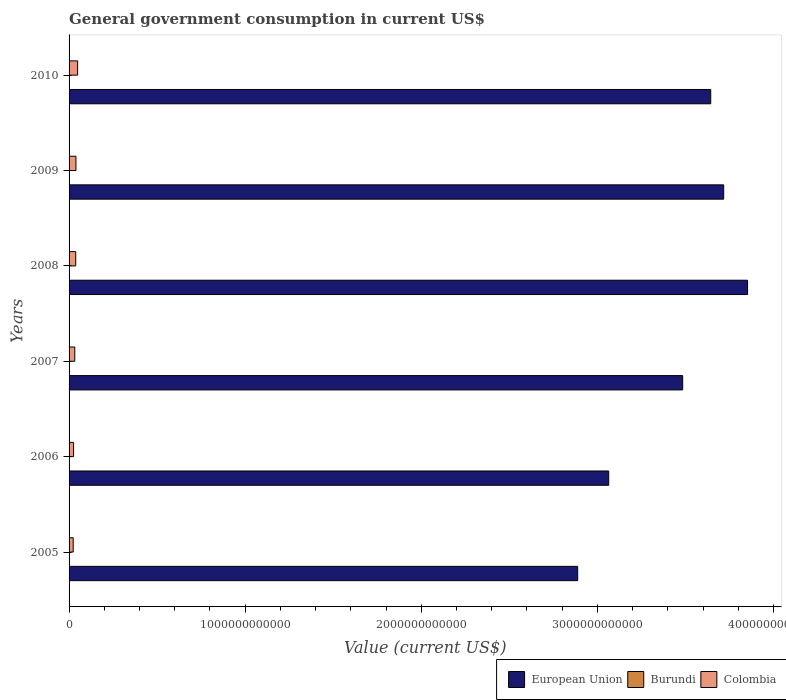How many different coloured bars are there?
Your answer should be compact. 3. How many groups of bars are there?
Offer a very short reply. 6. Are the number of bars per tick equal to the number of legend labels?
Keep it short and to the point. Yes. Are the number of bars on each tick of the Y-axis equal?
Keep it short and to the point. Yes. In how many cases, is the number of bars for a given year not equal to the number of legend labels?
Provide a succinct answer. 0. What is the government conusmption in European Union in 2007?
Your answer should be very brief. 3.48e+12. Across all years, what is the maximum government conusmption in Colombia?
Your answer should be compact. 4.86e+1. Across all years, what is the minimum government conusmption in Colombia?
Provide a short and direct response. 2.35e+1. In which year was the government conusmption in Colombia minimum?
Your answer should be compact. 2005. What is the total government conusmption in Colombia in the graph?
Your answer should be compact. 2.07e+11. What is the difference between the government conusmption in Burundi in 2005 and that in 2010?
Ensure brevity in your answer.  -4.28e+08. What is the difference between the government conusmption in Colombia in 2005 and the government conusmption in European Union in 2009?
Your response must be concise. -3.69e+12. What is the average government conusmption in Burundi per year?
Your answer should be compact. 4.12e+08. In the year 2010, what is the difference between the government conusmption in Burundi and government conusmption in European Union?
Offer a terse response. -3.64e+12. What is the ratio of the government conusmption in European Union in 2007 to that in 2008?
Make the answer very short. 0.9. Is the difference between the government conusmption in Burundi in 2008 and 2010 greater than the difference between the government conusmption in European Union in 2008 and 2010?
Provide a short and direct response. No. What is the difference between the highest and the second highest government conusmption in Colombia?
Your answer should be very brief. 9.53e+09. What is the difference between the highest and the lowest government conusmption in European Union?
Offer a very short reply. 9.65e+11. What does the 2nd bar from the top in 2008 represents?
Your answer should be very brief. Burundi. How many bars are there?
Your response must be concise. 18. Are all the bars in the graph horizontal?
Provide a succinct answer. Yes. How many years are there in the graph?
Provide a short and direct response. 6. What is the difference between two consecutive major ticks on the X-axis?
Your response must be concise. 1.00e+12. How many legend labels are there?
Give a very brief answer. 3. How are the legend labels stacked?
Provide a short and direct response. Horizontal. What is the title of the graph?
Ensure brevity in your answer.  General government consumption in current US$. What is the label or title of the X-axis?
Offer a very short reply. Value (current US$). What is the label or title of the Y-axis?
Your response must be concise. Years. What is the Value (current US$) of European Union in 2005?
Your response must be concise. 2.89e+12. What is the Value (current US$) in Burundi in 2005?
Make the answer very short. 2.12e+08. What is the Value (current US$) in Colombia in 2005?
Make the answer very short. 2.35e+1. What is the Value (current US$) in European Union in 2006?
Provide a short and direct response. 3.06e+12. What is the Value (current US$) of Burundi in 2006?
Give a very brief answer. 2.52e+08. What is the Value (current US$) in Colombia in 2006?
Your answer should be very brief. 2.55e+1. What is the Value (current US$) in European Union in 2007?
Make the answer very short. 3.48e+12. What is the Value (current US$) of Burundi in 2007?
Offer a terse response. 3.80e+08. What is the Value (current US$) in Colombia in 2007?
Your response must be concise. 3.24e+1. What is the Value (current US$) in European Union in 2008?
Your response must be concise. 3.85e+12. What is the Value (current US$) of Burundi in 2008?
Offer a very short reply. 4.86e+08. What is the Value (current US$) in Colombia in 2008?
Your response must be concise. 3.79e+1. What is the Value (current US$) of European Union in 2009?
Ensure brevity in your answer.  3.72e+12. What is the Value (current US$) of Burundi in 2009?
Give a very brief answer. 5.02e+08. What is the Value (current US$) of Colombia in 2009?
Give a very brief answer. 3.91e+1. What is the Value (current US$) in European Union in 2010?
Provide a succinct answer. 3.64e+12. What is the Value (current US$) of Burundi in 2010?
Provide a short and direct response. 6.40e+08. What is the Value (current US$) of Colombia in 2010?
Offer a very short reply. 4.86e+1. Across all years, what is the maximum Value (current US$) in European Union?
Provide a short and direct response. 3.85e+12. Across all years, what is the maximum Value (current US$) of Burundi?
Your answer should be compact. 6.40e+08. Across all years, what is the maximum Value (current US$) of Colombia?
Offer a very short reply. 4.86e+1. Across all years, what is the minimum Value (current US$) in European Union?
Your answer should be compact. 2.89e+12. Across all years, what is the minimum Value (current US$) of Burundi?
Keep it short and to the point. 2.12e+08. Across all years, what is the minimum Value (current US$) of Colombia?
Your answer should be very brief. 2.35e+1. What is the total Value (current US$) of European Union in the graph?
Keep it short and to the point. 2.07e+13. What is the total Value (current US$) of Burundi in the graph?
Provide a short and direct response. 2.47e+09. What is the total Value (current US$) of Colombia in the graph?
Offer a terse response. 2.07e+11. What is the difference between the Value (current US$) of European Union in 2005 and that in 2006?
Your response must be concise. -1.76e+11. What is the difference between the Value (current US$) in Burundi in 2005 and that in 2006?
Provide a succinct answer. -3.98e+07. What is the difference between the Value (current US$) in Colombia in 2005 and that in 2006?
Give a very brief answer. -2.08e+09. What is the difference between the Value (current US$) of European Union in 2005 and that in 2007?
Offer a very short reply. -5.96e+11. What is the difference between the Value (current US$) in Burundi in 2005 and that in 2007?
Your response must be concise. -1.68e+08. What is the difference between the Value (current US$) of Colombia in 2005 and that in 2007?
Keep it short and to the point. -8.99e+09. What is the difference between the Value (current US$) in European Union in 2005 and that in 2008?
Make the answer very short. -9.65e+11. What is the difference between the Value (current US$) in Burundi in 2005 and that in 2008?
Your answer should be very brief. -2.74e+08. What is the difference between the Value (current US$) of Colombia in 2005 and that in 2008?
Your response must be concise. -1.44e+1. What is the difference between the Value (current US$) of European Union in 2005 and that in 2009?
Offer a terse response. -8.29e+11. What is the difference between the Value (current US$) of Burundi in 2005 and that in 2009?
Offer a terse response. -2.90e+08. What is the difference between the Value (current US$) in Colombia in 2005 and that in 2009?
Give a very brief answer. -1.56e+1. What is the difference between the Value (current US$) of European Union in 2005 and that in 2010?
Provide a short and direct response. -7.56e+11. What is the difference between the Value (current US$) of Burundi in 2005 and that in 2010?
Ensure brevity in your answer.  -4.28e+08. What is the difference between the Value (current US$) in Colombia in 2005 and that in 2010?
Keep it short and to the point. -2.51e+1. What is the difference between the Value (current US$) in European Union in 2006 and that in 2007?
Give a very brief answer. -4.20e+11. What is the difference between the Value (current US$) of Burundi in 2006 and that in 2007?
Your response must be concise. -1.28e+08. What is the difference between the Value (current US$) of Colombia in 2006 and that in 2007?
Provide a succinct answer. -6.91e+09. What is the difference between the Value (current US$) in European Union in 2006 and that in 2008?
Provide a succinct answer. -7.89e+11. What is the difference between the Value (current US$) of Burundi in 2006 and that in 2008?
Provide a succinct answer. -2.34e+08. What is the difference between the Value (current US$) of Colombia in 2006 and that in 2008?
Offer a terse response. -1.23e+1. What is the difference between the Value (current US$) in European Union in 2006 and that in 2009?
Offer a very short reply. -6.53e+11. What is the difference between the Value (current US$) in Burundi in 2006 and that in 2009?
Your answer should be very brief. -2.50e+08. What is the difference between the Value (current US$) of Colombia in 2006 and that in 2009?
Make the answer very short. -1.35e+1. What is the difference between the Value (current US$) in European Union in 2006 and that in 2010?
Your answer should be very brief. -5.79e+11. What is the difference between the Value (current US$) in Burundi in 2006 and that in 2010?
Your answer should be very brief. -3.88e+08. What is the difference between the Value (current US$) in Colombia in 2006 and that in 2010?
Your answer should be very brief. -2.31e+1. What is the difference between the Value (current US$) of European Union in 2007 and that in 2008?
Offer a terse response. -3.68e+11. What is the difference between the Value (current US$) of Burundi in 2007 and that in 2008?
Provide a succinct answer. -1.06e+08. What is the difference between the Value (current US$) of Colombia in 2007 and that in 2008?
Provide a succinct answer. -5.42e+09. What is the difference between the Value (current US$) of European Union in 2007 and that in 2009?
Ensure brevity in your answer.  -2.33e+11. What is the difference between the Value (current US$) in Burundi in 2007 and that in 2009?
Your answer should be very brief. -1.22e+08. What is the difference between the Value (current US$) of Colombia in 2007 and that in 2009?
Provide a short and direct response. -6.62e+09. What is the difference between the Value (current US$) in European Union in 2007 and that in 2010?
Your response must be concise. -1.59e+11. What is the difference between the Value (current US$) in Burundi in 2007 and that in 2010?
Provide a short and direct response. -2.60e+08. What is the difference between the Value (current US$) of Colombia in 2007 and that in 2010?
Provide a succinct answer. -1.61e+1. What is the difference between the Value (current US$) in European Union in 2008 and that in 2009?
Offer a terse response. 1.36e+11. What is the difference between the Value (current US$) in Burundi in 2008 and that in 2009?
Ensure brevity in your answer.  -1.59e+07. What is the difference between the Value (current US$) in Colombia in 2008 and that in 2009?
Keep it short and to the point. -1.20e+09. What is the difference between the Value (current US$) of European Union in 2008 and that in 2010?
Make the answer very short. 2.09e+11. What is the difference between the Value (current US$) of Burundi in 2008 and that in 2010?
Your response must be concise. -1.54e+08. What is the difference between the Value (current US$) of Colombia in 2008 and that in 2010?
Ensure brevity in your answer.  -1.07e+1. What is the difference between the Value (current US$) of European Union in 2009 and that in 2010?
Your answer should be compact. 7.35e+1. What is the difference between the Value (current US$) in Burundi in 2009 and that in 2010?
Your answer should be compact. -1.38e+08. What is the difference between the Value (current US$) of Colombia in 2009 and that in 2010?
Your answer should be compact. -9.53e+09. What is the difference between the Value (current US$) of European Union in 2005 and the Value (current US$) of Burundi in 2006?
Ensure brevity in your answer.  2.89e+12. What is the difference between the Value (current US$) in European Union in 2005 and the Value (current US$) in Colombia in 2006?
Your response must be concise. 2.86e+12. What is the difference between the Value (current US$) in Burundi in 2005 and the Value (current US$) in Colombia in 2006?
Keep it short and to the point. -2.53e+1. What is the difference between the Value (current US$) of European Union in 2005 and the Value (current US$) of Burundi in 2007?
Offer a terse response. 2.89e+12. What is the difference between the Value (current US$) of European Union in 2005 and the Value (current US$) of Colombia in 2007?
Give a very brief answer. 2.86e+12. What is the difference between the Value (current US$) of Burundi in 2005 and the Value (current US$) of Colombia in 2007?
Your answer should be compact. -3.22e+1. What is the difference between the Value (current US$) of European Union in 2005 and the Value (current US$) of Burundi in 2008?
Your answer should be compact. 2.89e+12. What is the difference between the Value (current US$) of European Union in 2005 and the Value (current US$) of Colombia in 2008?
Offer a terse response. 2.85e+12. What is the difference between the Value (current US$) in Burundi in 2005 and the Value (current US$) in Colombia in 2008?
Make the answer very short. -3.76e+1. What is the difference between the Value (current US$) in European Union in 2005 and the Value (current US$) in Burundi in 2009?
Your response must be concise. 2.89e+12. What is the difference between the Value (current US$) in European Union in 2005 and the Value (current US$) in Colombia in 2009?
Your answer should be compact. 2.85e+12. What is the difference between the Value (current US$) of Burundi in 2005 and the Value (current US$) of Colombia in 2009?
Provide a short and direct response. -3.88e+1. What is the difference between the Value (current US$) of European Union in 2005 and the Value (current US$) of Burundi in 2010?
Your answer should be compact. 2.89e+12. What is the difference between the Value (current US$) of European Union in 2005 and the Value (current US$) of Colombia in 2010?
Offer a terse response. 2.84e+12. What is the difference between the Value (current US$) in Burundi in 2005 and the Value (current US$) in Colombia in 2010?
Your response must be concise. -4.84e+1. What is the difference between the Value (current US$) in European Union in 2006 and the Value (current US$) in Burundi in 2007?
Ensure brevity in your answer.  3.06e+12. What is the difference between the Value (current US$) of European Union in 2006 and the Value (current US$) of Colombia in 2007?
Ensure brevity in your answer.  3.03e+12. What is the difference between the Value (current US$) in Burundi in 2006 and the Value (current US$) in Colombia in 2007?
Give a very brief answer. -3.22e+1. What is the difference between the Value (current US$) of European Union in 2006 and the Value (current US$) of Burundi in 2008?
Give a very brief answer. 3.06e+12. What is the difference between the Value (current US$) in European Union in 2006 and the Value (current US$) in Colombia in 2008?
Provide a succinct answer. 3.03e+12. What is the difference between the Value (current US$) in Burundi in 2006 and the Value (current US$) in Colombia in 2008?
Your response must be concise. -3.76e+1. What is the difference between the Value (current US$) in European Union in 2006 and the Value (current US$) in Burundi in 2009?
Provide a succinct answer. 3.06e+12. What is the difference between the Value (current US$) in European Union in 2006 and the Value (current US$) in Colombia in 2009?
Your answer should be very brief. 3.03e+12. What is the difference between the Value (current US$) in Burundi in 2006 and the Value (current US$) in Colombia in 2009?
Your answer should be very brief. -3.88e+1. What is the difference between the Value (current US$) of European Union in 2006 and the Value (current US$) of Burundi in 2010?
Your response must be concise. 3.06e+12. What is the difference between the Value (current US$) in European Union in 2006 and the Value (current US$) in Colombia in 2010?
Make the answer very short. 3.02e+12. What is the difference between the Value (current US$) in Burundi in 2006 and the Value (current US$) in Colombia in 2010?
Give a very brief answer. -4.83e+1. What is the difference between the Value (current US$) of European Union in 2007 and the Value (current US$) of Burundi in 2008?
Your answer should be very brief. 3.48e+12. What is the difference between the Value (current US$) of European Union in 2007 and the Value (current US$) of Colombia in 2008?
Offer a terse response. 3.45e+12. What is the difference between the Value (current US$) in Burundi in 2007 and the Value (current US$) in Colombia in 2008?
Your answer should be very brief. -3.75e+1. What is the difference between the Value (current US$) of European Union in 2007 and the Value (current US$) of Burundi in 2009?
Provide a succinct answer. 3.48e+12. What is the difference between the Value (current US$) of European Union in 2007 and the Value (current US$) of Colombia in 2009?
Give a very brief answer. 3.45e+12. What is the difference between the Value (current US$) of Burundi in 2007 and the Value (current US$) of Colombia in 2009?
Offer a terse response. -3.87e+1. What is the difference between the Value (current US$) in European Union in 2007 and the Value (current US$) in Burundi in 2010?
Provide a short and direct response. 3.48e+12. What is the difference between the Value (current US$) in European Union in 2007 and the Value (current US$) in Colombia in 2010?
Provide a short and direct response. 3.44e+12. What is the difference between the Value (current US$) of Burundi in 2007 and the Value (current US$) of Colombia in 2010?
Your response must be concise. -4.82e+1. What is the difference between the Value (current US$) in European Union in 2008 and the Value (current US$) in Burundi in 2009?
Ensure brevity in your answer.  3.85e+12. What is the difference between the Value (current US$) of European Union in 2008 and the Value (current US$) of Colombia in 2009?
Your answer should be compact. 3.81e+12. What is the difference between the Value (current US$) in Burundi in 2008 and the Value (current US$) in Colombia in 2009?
Ensure brevity in your answer.  -3.86e+1. What is the difference between the Value (current US$) of European Union in 2008 and the Value (current US$) of Burundi in 2010?
Give a very brief answer. 3.85e+12. What is the difference between the Value (current US$) of European Union in 2008 and the Value (current US$) of Colombia in 2010?
Keep it short and to the point. 3.80e+12. What is the difference between the Value (current US$) of Burundi in 2008 and the Value (current US$) of Colombia in 2010?
Make the answer very short. -4.81e+1. What is the difference between the Value (current US$) of European Union in 2009 and the Value (current US$) of Burundi in 2010?
Ensure brevity in your answer.  3.72e+12. What is the difference between the Value (current US$) in European Union in 2009 and the Value (current US$) in Colombia in 2010?
Ensure brevity in your answer.  3.67e+12. What is the difference between the Value (current US$) in Burundi in 2009 and the Value (current US$) in Colombia in 2010?
Ensure brevity in your answer.  -4.81e+1. What is the average Value (current US$) of European Union per year?
Provide a succinct answer. 3.44e+12. What is the average Value (current US$) in Burundi per year?
Offer a terse response. 4.12e+08. What is the average Value (current US$) in Colombia per year?
Ensure brevity in your answer.  3.45e+1. In the year 2005, what is the difference between the Value (current US$) of European Union and Value (current US$) of Burundi?
Provide a short and direct response. 2.89e+12. In the year 2005, what is the difference between the Value (current US$) in European Union and Value (current US$) in Colombia?
Ensure brevity in your answer.  2.86e+12. In the year 2005, what is the difference between the Value (current US$) of Burundi and Value (current US$) of Colombia?
Provide a succinct answer. -2.32e+1. In the year 2006, what is the difference between the Value (current US$) of European Union and Value (current US$) of Burundi?
Provide a short and direct response. 3.06e+12. In the year 2006, what is the difference between the Value (current US$) of European Union and Value (current US$) of Colombia?
Make the answer very short. 3.04e+12. In the year 2006, what is the difference between the Value (current US$) in Burundi and Value (current US$) in Colombia?
Make the answer very short. -2.53e+1. In the year 2007, what is the difference between the Value (current US$) in European Union and Value (current US$) in Burundi?
Your answer should be compact. 3.48e+12. In the year 2007, what is the difference between the Value (current US$) of European Union and Value (current US$) of Colombia?
Offer a very short reply. 3.45e+12. In the year 2007, what is the difference between the Value (current US$) in Burundi and Value (current US$) in Colombia?
Your response must be concise. -3.21e+1. In the year 2008, what is the difference between the Value (current US$) in European Union and Value (current US$) in Burundi?
Make the answer very short. 3.85e+12. In the year 2008, what is the difference between the Value (current US$) in European Union and Value (current US$) in Colombia?
Offer a terse response. 3.81e+12. In the year 2008, what is the difference between the Value (current US$) in Burundi and Value (current US$) in Colombia?
Your response must be concise. -3.74e+1. In the year 2009, what is the difference between the Value (current US$) in European Union and Value (current US$) in Burundi?
Ensure brevity in your answer.  3.72e+12. In the year 2009, what is the difference between the Value (current US$) in European Union and Value (current US$) in Colombia?
Provide a succinct answer. 3.68e+12. In the year 2009, what is the difference between the Value (current US$) of Burundi and Value (current US$) of Colombia?
Provide a succinct answer. -3.86e+1. In the year 2010, what is the difference between the Value (current US$) of European Union and Value (current US$) of Burundi?
Your answer should be compact. 3.64e+12. In the year 2010, what is the difference between the Value (current US$) of European Union and Value (current US$) of Colombia?
Offer a very short reply. 3.60e+12. In the year 2010, what is the difference between the Value (current US$) of Burundi and Value (current US$) of Colombia?
Provide a short and direct response. -4.79e+1. What is the ratio of the Value (current US$) of European Union in 2005 to that in 2006?
Offer a very short reply. 0.94. What is the ratio of the Value (current US$) in Burundi in 2005 to that in 2006?
Ensure brevity in your answer.  0.84. What is the ratio of the Value (current US$) of Colombia in 2005 to that in 2006?
Provide a short and direct response. 0.92. What is the ratio of the Value (current US$) of European Union in 2005 to that in 2007?
Keep it short and to the point. 0.83. What is the ratio of the Value (current US$) in Burundi in 2005 to that in 2007?
Your answer should be very brief. 0.56. What is the ratio of the Value (current US$) of Colombia in 2005 to that in 2007?
Keep it short and to the point. 0.72. What is the ratio of the Value (current US$) in European Union in 2005 to that in 2008?
Keep it short and to the point. 0.75. What is the ratio of the Value (current US$) in Burundi in 2005 to that in 2008?
Offer a very short reply. 0.44. What is the ratio of the Value (current US$) of Colombia in 2005 to that in 2008?
Your response must be concise. 0.62. What is the ratio of the Value (current US$) of European Union in 2005 to that in 2009?
Offer a terse response. 0.78. What is the ratio of the Value (current US$) in Burundi in 2005 to that in 2009?
Give a very brief answer. 0.42. What is the ratio of the Value (current US$) of Colombia in 2005 to that in 2009?
Provide a short and direct response. 0.6. What is the ratio of the Value (current US$) of European Union in 2005 to that in 2010?
Make the answer very short. 0.79. What is the ratio of the Value (current US$) in Burundi in 2005 to that in 2010?
Your answer should be compact. 0.33. What is the ratio of the Value (current US$) in Colombia in 2005 to that in 2010?
Offer a terse response. 0.48. What is the ratio of the Value (current US$) in European Union in 2006 to that in 2007?
Provide a short and direct response. 0.88. What is the ratio of the Value (current US$) of Burundi in 2006 to that in 2007?
Make the answer very short. 0.66. What is the ratio of the Value (current US$) in Colombia in 2006 to that in 2007?
Make the answer very short. 0.79. What is the ratio of the Value (current US$) of European Union in 2006 to that in 2008?
Provide a succinct answer. 0.8. What is the ratio of the Value (current US$) in Burundi in 2006 to that in 2008?
Make the answer very short. 0.52. What is the ratio of the Value (current US$) in Colombia in 2006 to that in 2008?
Provide a short and direct response. 0.67. What is the ratio of the Value (current US$) of European Union in 2006 to that in 2009?
Give a very brief answer. 0.82. What is the ratio of the Value (current US$) in Burundi in 2006 to that in 2009?
Ensure brevity in your answer.  0.5. What is the ratio of the Value (current US$) of Colombia in 2006 to that in 2009?
Ensure brevity in your answer.  0.65. What is the ratio of the Value (current US$) in European Union in 2006 to that in 2010?
Ensure brevity in your answer.  0.84. What is the ratio of the Value (current US$) of Burundi in 2006 to that in 2010?
Offer a terse response. 0.39. What is the ratio of the Value (current US$) of Colombia in 2006 to that in 2010?
Keep it short and to the point. 0.53. What is the ratio of the Value (current US$) of European Union in 2007 to that in 2008?
Offer a very short reply. 0.9. What is the ratio of the Value (current US$) in Burundi in 2007 to that in 2008?
Keep it short and to the point. 0.78. What is the ratio of the Value (current US$) of Colombia in 2007 to that in 2008?
Offer a very short reply. 0.86. What is the ratio of the Value (current US$) in European Union in 2007 to that in 2009?
Your answer should be compact. 0.94. What is the ratio of the Value (current US$) in Burundi in 2007 to that in 2009?
Offer a terse response. 0.76. What is the ratio of the Value (current US$) of Colombia in 2007 to that in 2009?
Keep it short and to the point. 0.83. What is the ratio of the Value (current US$) in European Union in 2007 to that in 2010?
Give a very brief answer. 0.96. What is the ratio of the Value (current US$) of Burundi in 2007 to that in 2010?
Offer a very short reply. 0.59. What is the ratio of the Value (current US$) of Colombia in 2007 to that in 2010?
Your response must be concise. 0.67. What is the ratio of the Value (current US$) of European Union in 2008 to that in 2009?
Your answer should be compact. 1.04. What is the ratio of the Value (current US$) of Burundi in 2008 to that in 2009?
Your answer should be very brief. 0.97. What is the ratio of the Value (current US$) in Colombia in 2008 to that in 2009?
Make the answer very short. 0.97. What is the ratio of the Value (current US$) in European Union in 2008 to that in 2010?
Your response must be concise. 1.06. What is the ratio of the Value (current US$) in Burundi in 2008 to that in 2010?
Keep it short and to the point. 0.76. What is the ratio of the Value (current US$) of Colombia in 2008 to that in 2010?
Offer a terse response. 0.78. What is the ratio of the Value (current US$) of European Union in 2009 to that in 2010?
Offer a very short reply. 1.02. What is the ratio of the Value (current US$) in Burundi in 2009 to that in 2010?
Your answer should be compact. 0.78. What is the ratio of the Value (current US$) of Colombia in 2009 to that in 2010?
Offer a terse response. 0.8. What is the difference between the highest and the second highest Value (current US$) of European Union?
Your answer should be very brief. 1.36e+11. What is the difference between the highest and the second highest Value (current US$) of Burundi?
Offer a very short reply. 1.38e+08. What is the difference between the highest and the second highest Value (current US$) in Colombia?
Make the answer very short. 9.53e+09. What is the difference between the highest and the lowest Value (current US$) of European Union?
Offer a very short reply. 9.65e+11. What is the difference between the highest and the lowest Value (current US$) in Burundi?
Provide a short and direct response. 4.28e+08. What is the difference between the highest and the lowest Value (current US$) of Colombia?
Offer a very short reply. 2.51e+1. 